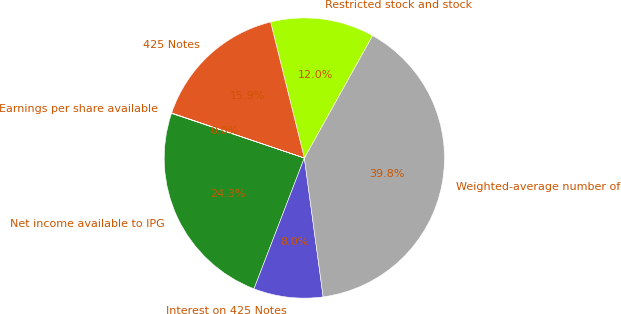Convert chart. <chart><loc_0><loc_0><loc_500><loc_500><pie_chart><fcel>Net income available to IPG<fcel>Interest on 425 Notes<fcel>Weighted-average number of<fcel>Restricted stock and stock<fcel>425 Notes<fcel>Earnings per share available<nl><fcel>24.32%<fcel>7.99%<fcel>39.77%<fcel>11.96%<fcel>15.93%<fcel>0.04%<nl></chart> 